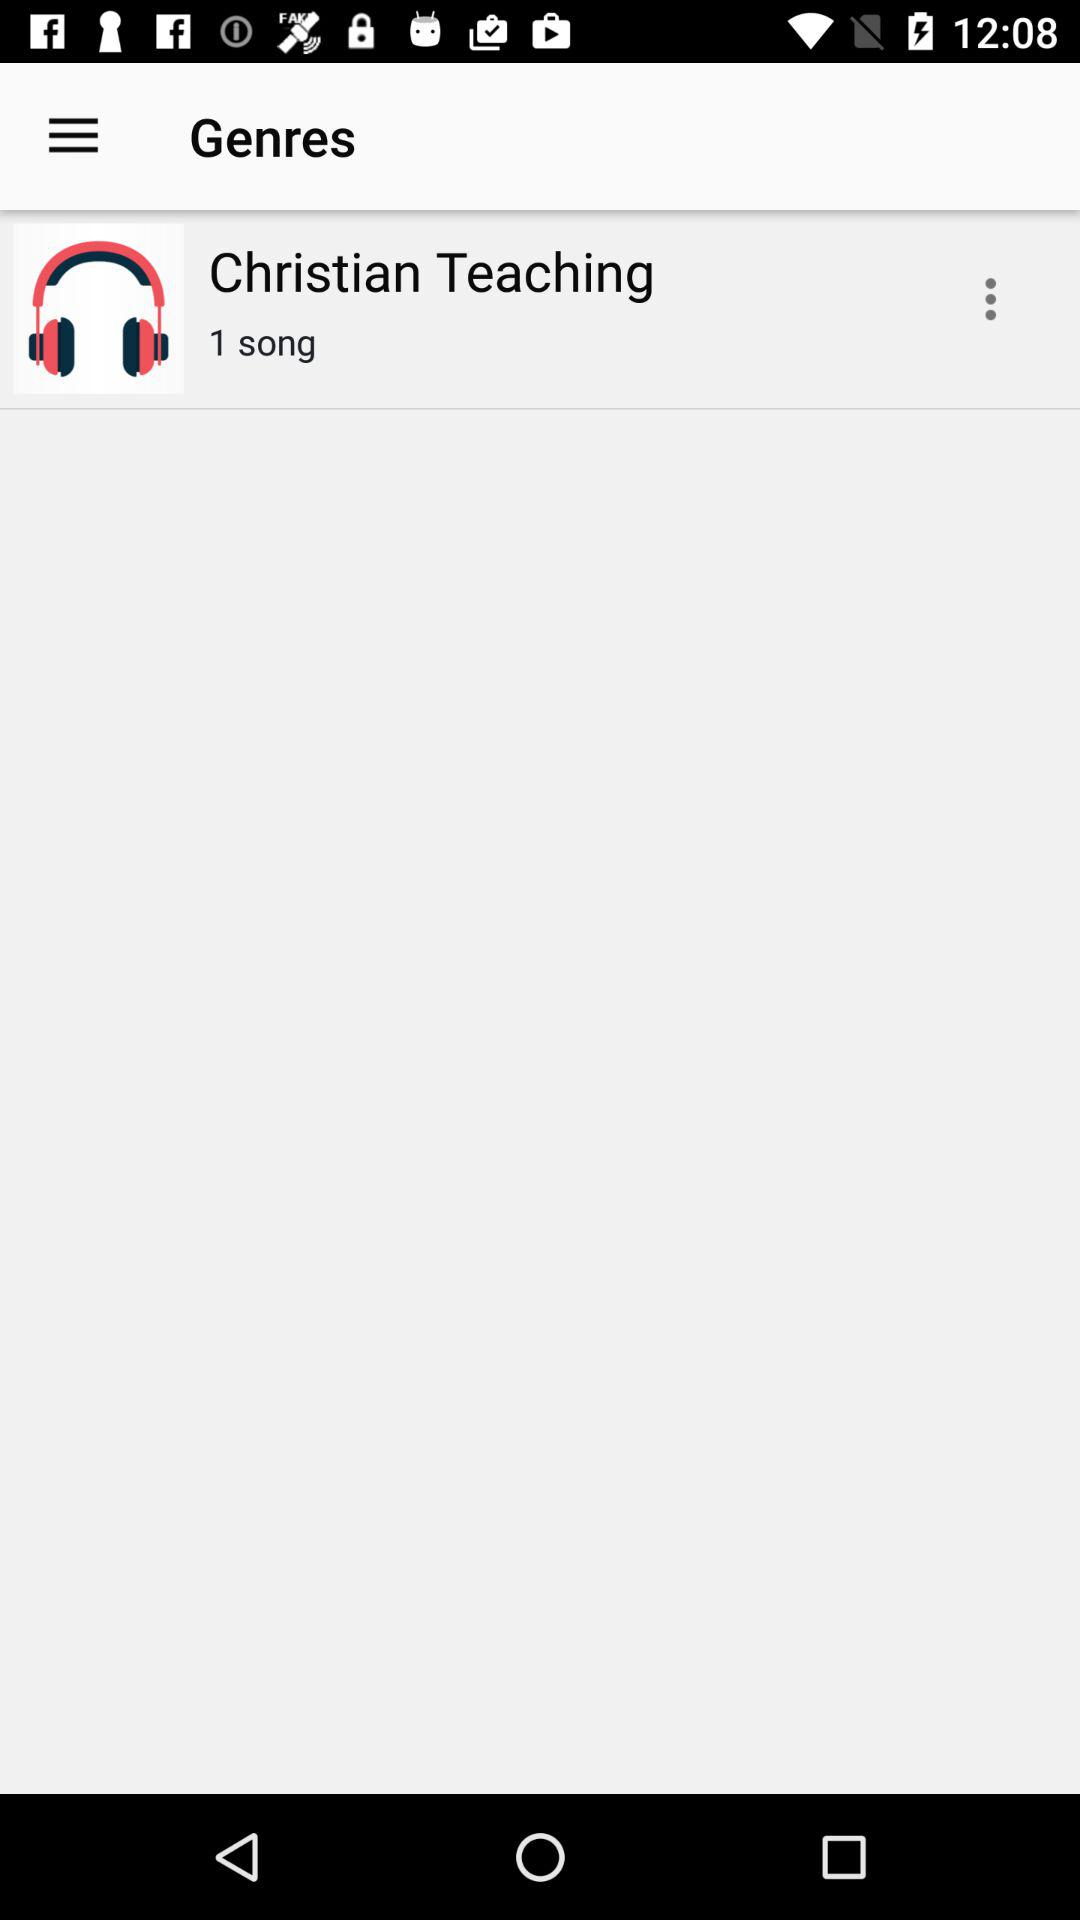How many songs are in the Christian Teaching genre?
Answer the question using a single word or phrase. 1 